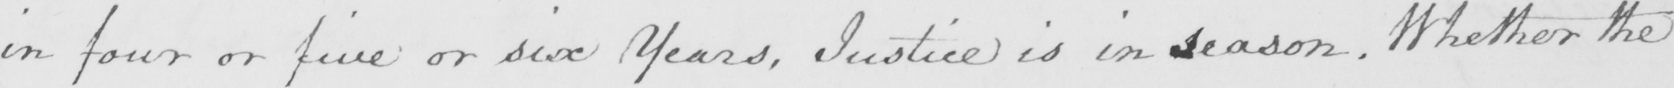Please transcribe the handwritten text in this image. in four or five or six Years , Justice is in season . Whether the 